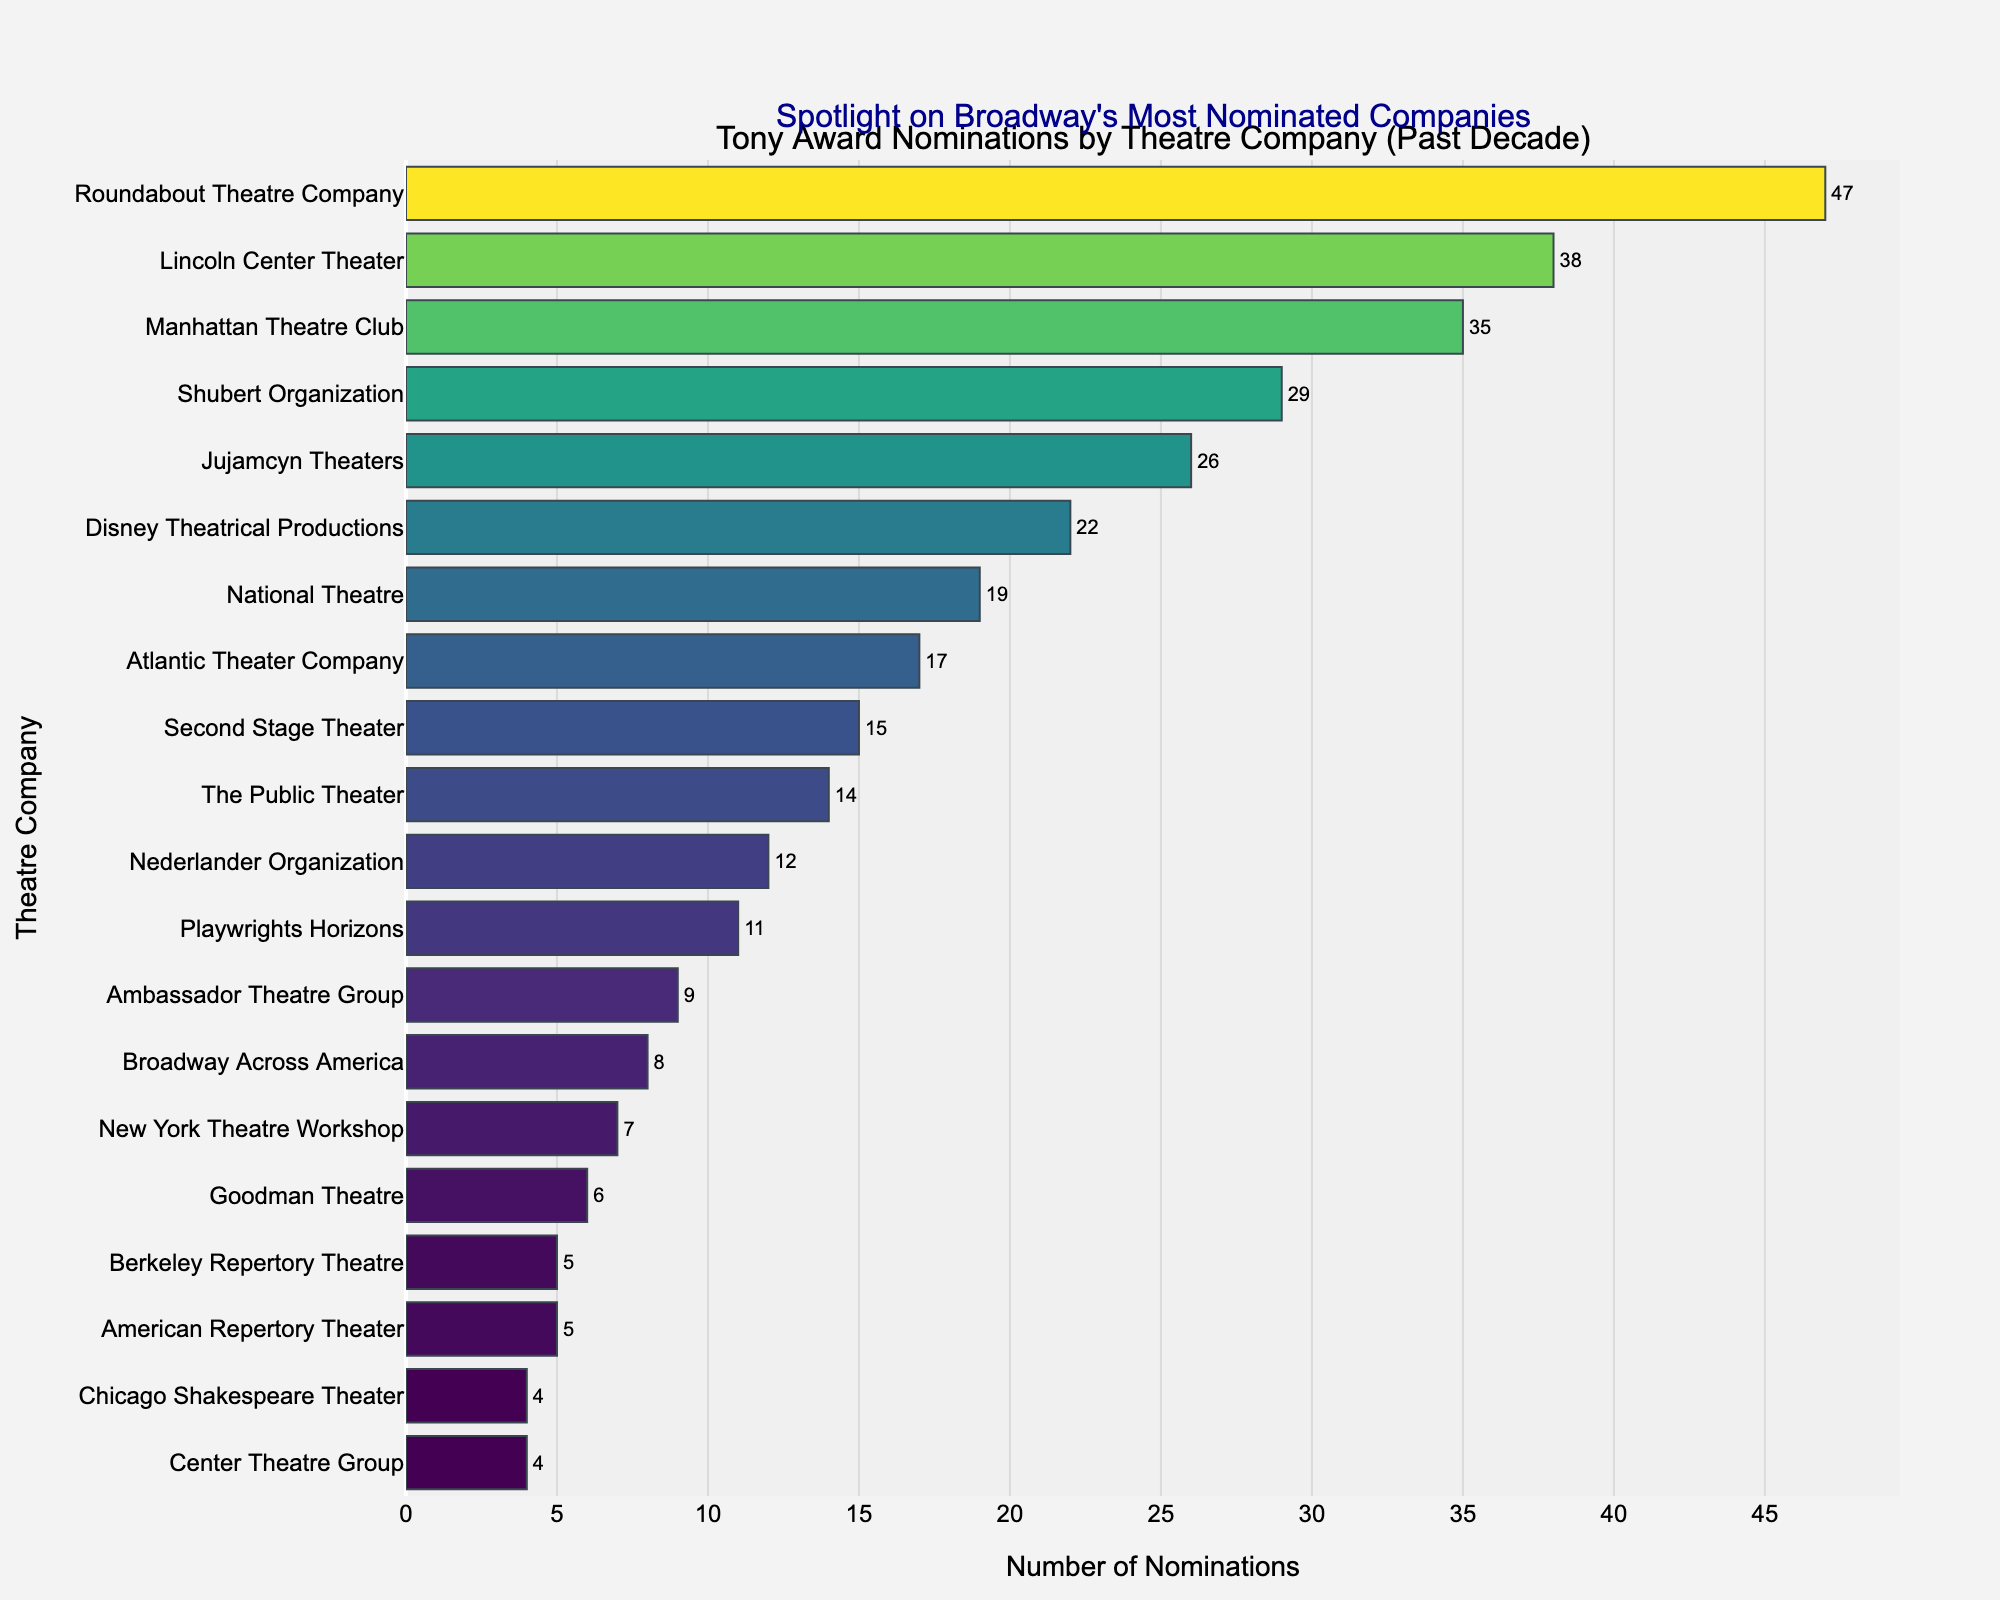Which theatre company has the highest number of Tony Award nominations? The company with the longest bar in the figure represents the highest number of nominations. In this case, it's the Roundabout Theatre Company.
Answer: Roundabout Theatre Company Which theatre company has the lowest number of Tony Award nominations in the past decade? The company with the shortest bar in the figure represents the lowest number of nominations. This is the Center Theatre Group and Chicago Shakespeare Theater, both tied at four nominations.
Answer: Center Theatre Group and Chicago Shakespeare Theater How many more nominations does the Roundabout Theatre Company have compared to the Disney Theatrical Productions? The Roundabout Theatre Company has 47 nominations, and Disney Theatrical Productions has 22 nominations. Subtract 22 from 47 to find the difference: 47 - 22 = 25.
Answer: 25 What is the combined total of Tony Award nominations for Lincoln Center Theater and Manhattan Theatre Club? Lincoln Center Theater has 38 nominations, while Manhattan Theatre Club has 35 nominations. Add these figures together: 38 + 35 = 73.
Answer: 73 Which company ranks third in terms of Tony Award nominations? By examining the order of the bars from highest to lowest, the company with the third longest bar is the Manhattan Theatre Club.
Answer: Manhattan Theatre Club Are there any theatre companies with an equal number of nominations? If so, which ones? By looking at the lengths of the bars, it is observable that both Goodman Theatre and American Repertory Theater each have 5 nominations.
Answer: Goodman Theatre and American Repertory Theater What is the median number of Tony Award nominations among the listed companies, and which company or companies are nearest to this median? Arrange the nominations in ascending order and find the middle value. The ordered list: 4, 4, 5, 5, 6, 7, 8, 9, 11, 12, 14, 15, 17, 19, 22, 26, 29, 35, 38, 47. With 20 points, the median is (12+14)/2 = 13. The closest company is The Public Theater with 14 nominations.
Answer: The Public Theater What is the range of Tony Award nominations among the theatre companies? The range is calculated by subtracting the smallest number of nominations from the largest number. 47 (Roundabout Theatre Company) - 4 (Center Theatre Group and Chicago Shakespeare Theater) = 43.
Answer: 43 